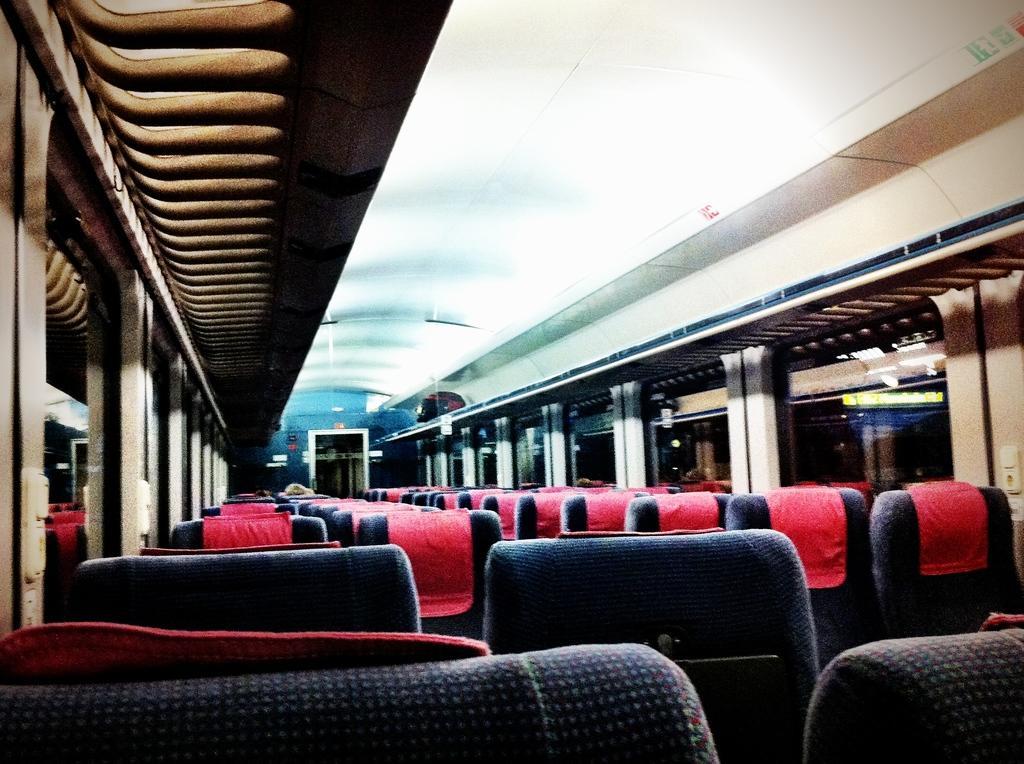Can you describe this image briefly? In this image I can see the inner part of the vehicle. I can also see few chairs in blue and red color, and I can see few glass windows. 